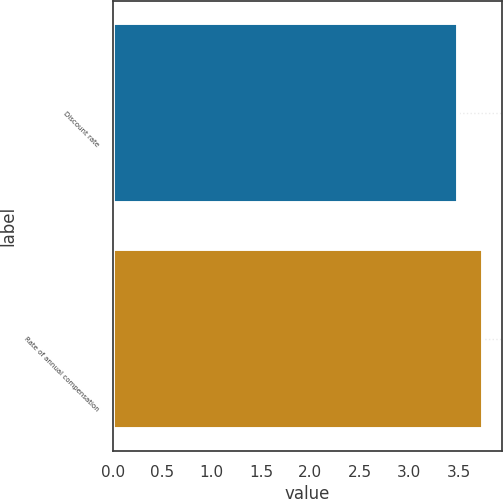<chart> <loc_0><loc_0><loc_500><loc_500><bar_chart><fcel>Discount rate<fcel>Rate of annual compensation<nl><fcel>3.49<fcel>3.75<nl></chart> 